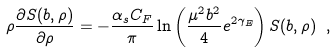Convert formula to latex. <formula><loc_0><loc_0><loc_500><loc_500>\rho \frac { \partial S ( b , \rho ) } { \partial \rho } = - \frac { \alpha _ { s } C _ { F } } { \pi } \ln \left ( \frac { \mu ^ { 2 } b ^ { 2 } } { 4 } e ^ { 2 \gamma _ { E } } \right ) S ( b , \rho ) \ ,</formula> 